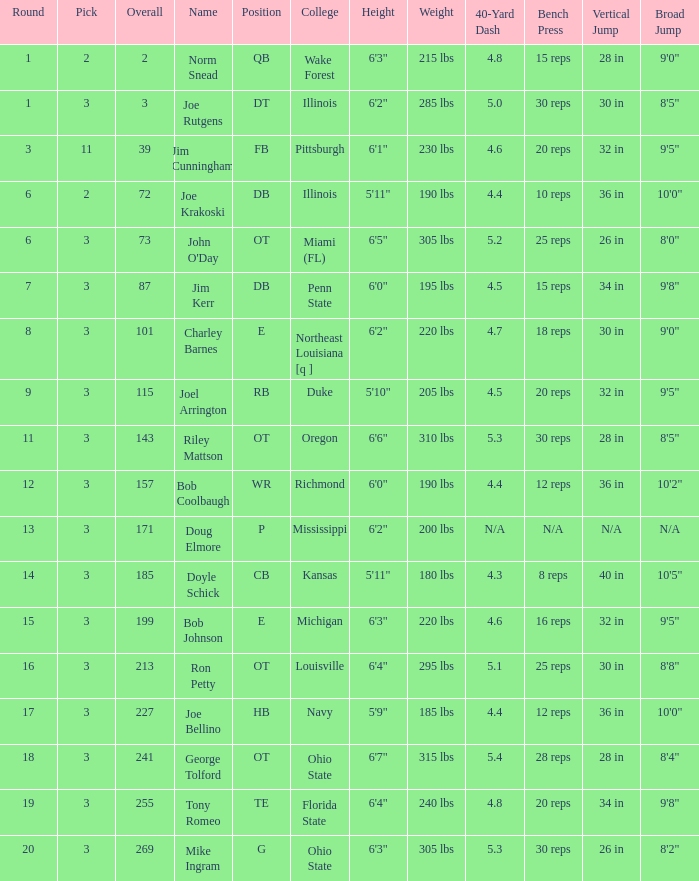How many rounds have john o'day as the name, and a pick less than 3? None. 